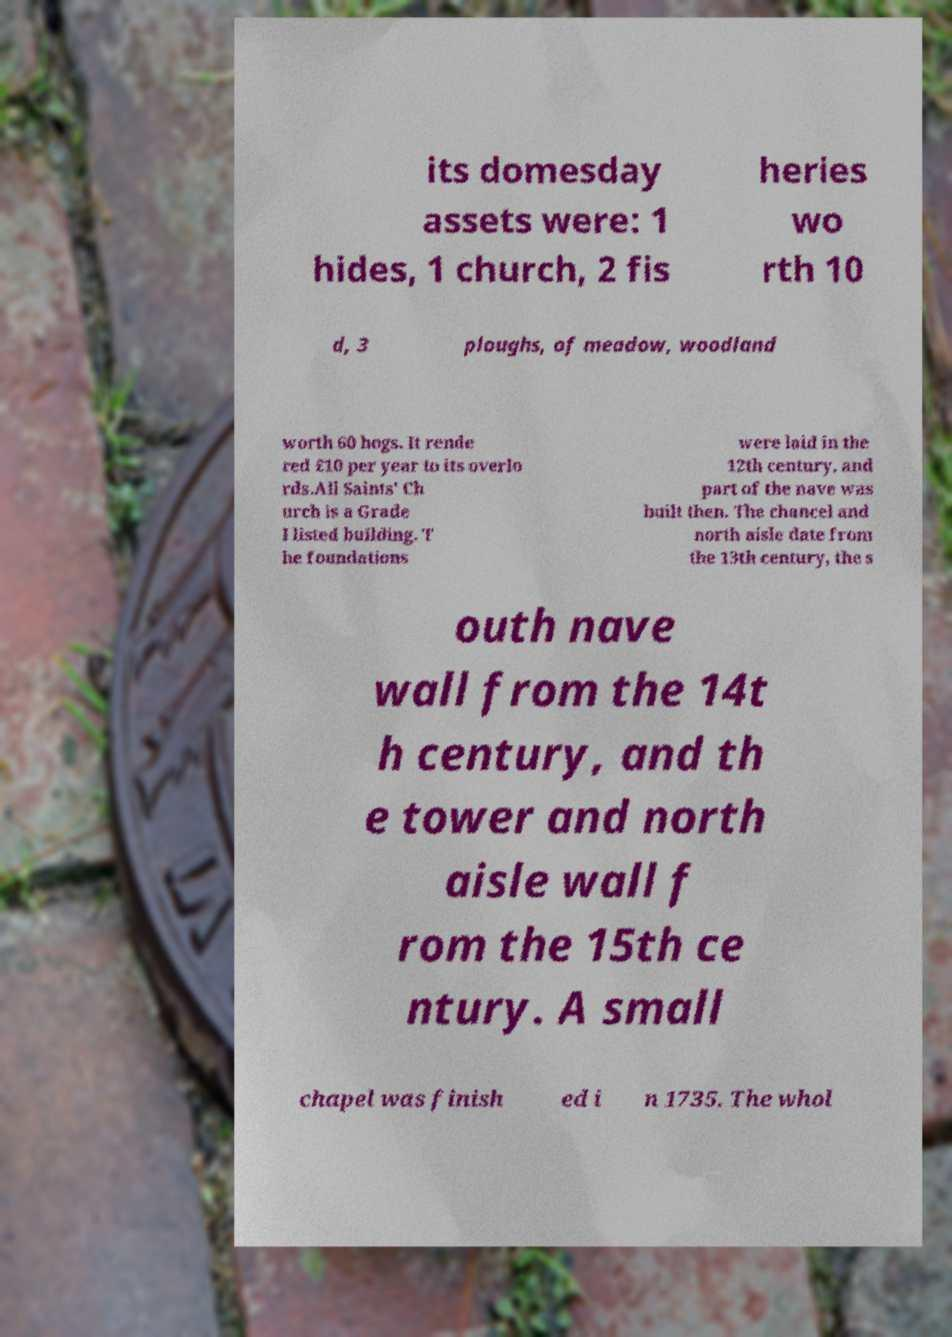Can you read and provide the text displayed in the image?This photo seems to have some interesting text. Can you extract and type it out for me? its domesday assets were: 1 hides, 1 church, 2 fis heries wo rth 10 d, 3 ploughs, of meadow, woodland worth 60 hogs. It rende red £10 per year to its overlo rds.All Saints' Ch urch is a Grade I listed building. T he foundations were laid in the 12th century, and part of the nave was built then. The chancel and north aisle date from the 13th century, the s outh nave wall from the 14t h century, and th e tower and north aisle wall f rom the 15th ce ntury. A small chapel was finish ed i n 1735. The whol 